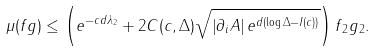Convert formula to latex. <formula><loc_0><loc_0><loc_500><loc_500>\mu ( f g ) \leq \left ( e ^ { - c d \lambda _ { 2 } } + 2 C ( c , \Delta ) \sqrt { \left | \partial _ { i } A \right | e ^ { d \left ( \log \Delta - I ( c ) \right ) } } \right ) \| f \| _ { 2 } \| g \| _ { 2 } .</formula> 